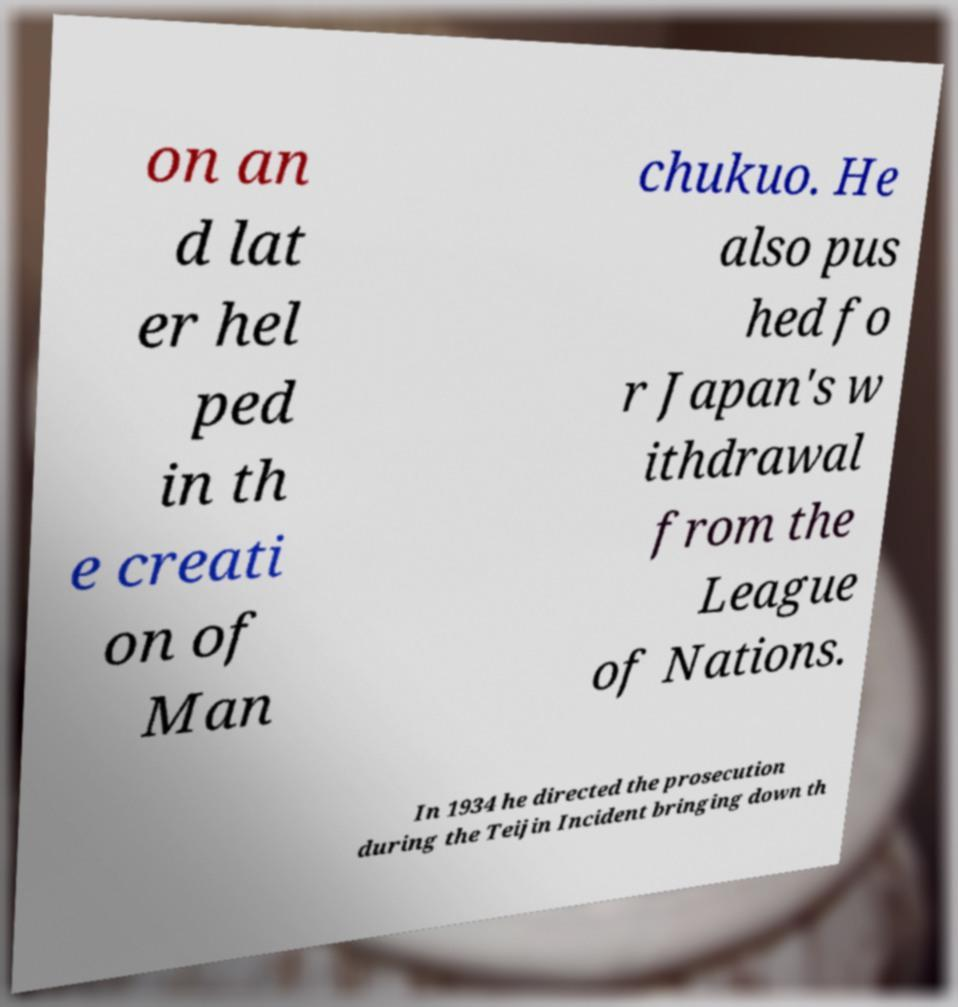What messages or text are displayed in this image? I need them in a readable, typed format. on an d lat er hel ped in th e creati on of Man chukuo. He also pus hed fo r Japan's w ithdrawal from the League of Nations. In 1934 he directed the prosecution during the Teijin Incident bringing down th 